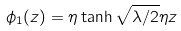<formula> <loc_0><loc_0><loc_500><loc_500>\phi _ { 1 } ( z ) = \eta \tanh \sqrt { \lambda / 2 } \eta z</formula> 